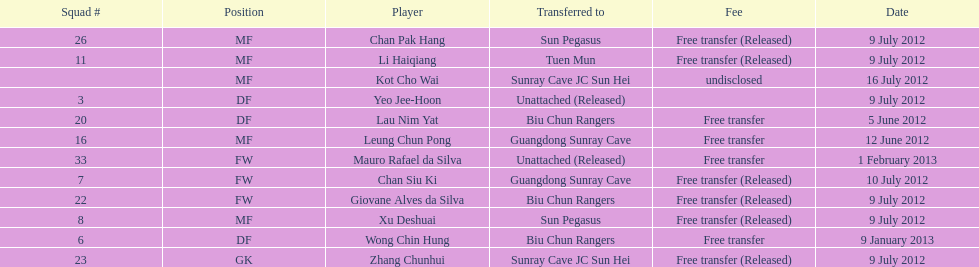Could you parse the entire table? {'header': ['Squad #', 'Position', 'Player', 'Transferred to', 'Fee', 'Date'], 'rows': [['26', 'MF', 'Chan Pak Hang', 'Sun Pegasus', 'Free transfer (Released)', '9 July 2012'], ['11', 'MF', 'Li Haiqiang', 'Tuen Mun', 'Free transfer (Released)', '9 July 2012'], ['', 'MF', 'Kot Cho Wai', 'Sunray Cave JC Sun Hei', 'undisclosed', '16 July 2012'], ['3', 'DF', 'Yeo Jee-Hoon', 'Unattached (Released)', '', '9 July 2012'], ['20', 'DF', 'Lau Nim Yat', 'Biu Chun Rangers', 'Free transfer', '5 June 2012'], ['16', 'MF', 'Leung Chun Pong', 'Guangdong Sunray Cave', 'Free transfer', '12 June 2012'], ['33', 'FW', 'Mauro Rafael da Silva', 'Unattached (Released)', 'Free transfer', '1 February 2013'], ['7', 'FW', 'Chan Siu Ki', 'Guangdong Sunray Cave', 'Free transfer (Released)', '10 July 2012'], ['22', 'FW', 'Giovane Alves da Silva', 'Biu Chun Rangers', 'Free transfer (Released)', '9 July 2012'], ['8', 'MF', 'Xu Deshuai', 'Sun Pegasus', 'Free transfer (Released)', '9 July 2012'], ['6', 'DF', 'Wong Chin Hung', 'Biu Chun Rangers', 'Free transfer', '9 January 2013'], ['23', 'GK', 'Zhang Chunhui', 'Sunray Cave JC Sun Hei', 'Free transfer (Released)', '9 July 2012']]} What position is next to squad # 3? DF. 